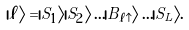Convert formula to latex. <formula><loc_0><loc_0><loc_500><loc_500>| \ell \rangle = | S _ { 1 } \rangle | S _ { 2 } \rangle \dots | B _ { \ell \uparrow } \rangle \dots | S _ { L } \rangle .</formula> 